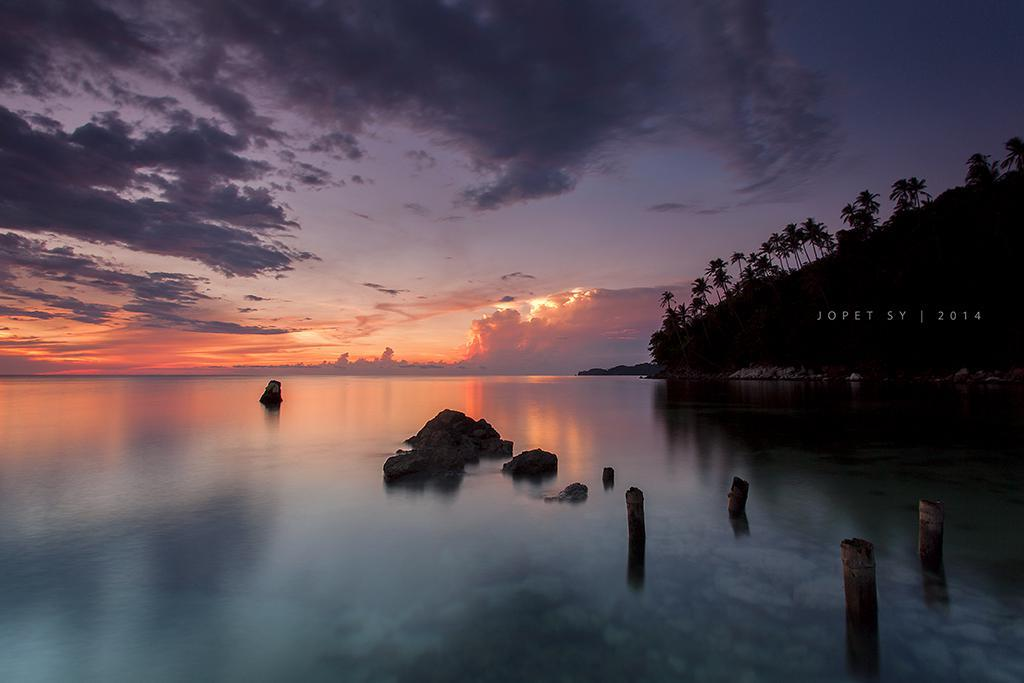What is the main element present in the image? There is water in the image. What other objects or features can be seen in the image? There are rocks and trees in the image. What is visible in the background of the image? The sky is visible in the image. What can be observed in the sky? Clouds are present in the sky. What type of plot is being cultivated in the image? There is no plot present in the image; it features water, rocks, trees, and a sky with clouds. What is the slope of the terrain in the image? There is no slope mentioned or visible in the image; it appears to be a relatively flat landscape. 